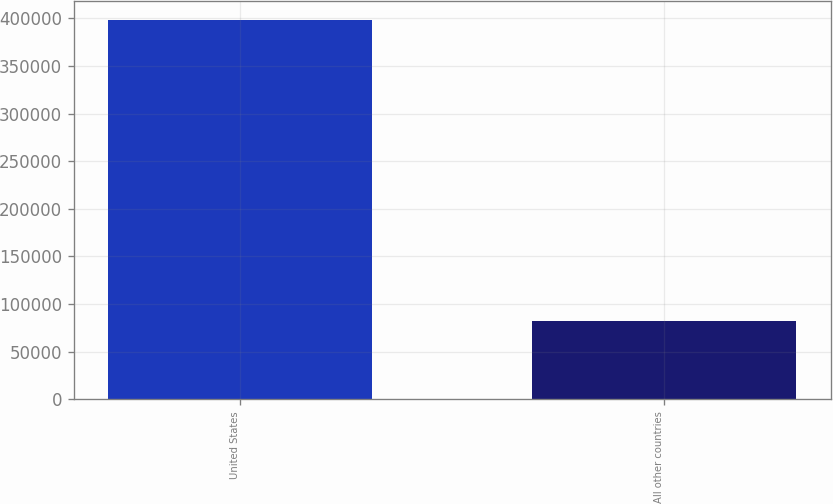<chart> <loc_0><loc_0><loc_500><loc_500><bar_chart><fcel>United States<fcel>All other countries<nl><fcel>398384<fcel>82318<nl></chart> 